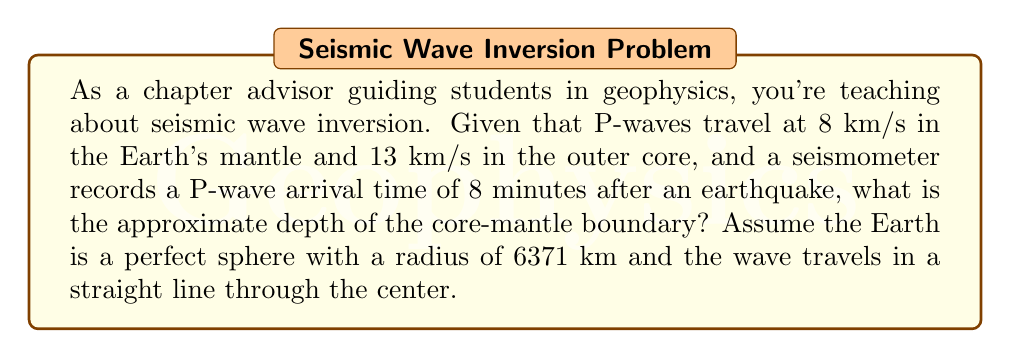Solve this math problem. Let's approach this step-by-step:

1) First, we need to set up our equation. Let $x$ be the distance the wave travels in the mantle, and $y$ be the distance in the core.

2) We know that the total distance is the diameter of the Earth:
   $$x + y = 2 * 6371 = 12742 \text{ km}$$

3) We can express the total time $t$ as the sum of time in mantle and core:
   $$t = \frac{x}{v_m} + \frac{y}{v_c}$$
   where $v_m = 8 \text{ km/s}$ and $v_c = 13 \text{ km/s}$

4) We know $t = 8 \text{ minutes} = 480 \text{ seconds}$. Substituting all known values:
   $$480 = \frac{x}{8} + \frac{12742-x}{13}$$

5) Multiply both sides by 104 (LCM of 8 and 13):
   $$49920 = 13x + 8(12742-x) = 13x + 101936 - 8x = 5x + 101936$$

6) Subtract 101936 from both sides:
   $$-52016 = 5x$$

7) Divide by 5:
   $$x = -10403.2 \text{ km}$$

8) The negative value indicates the wave travels 10403.2 km in the mantle before reaching the core.

9) The depth of the core-mantle boundary is therefore:
   $$6371 - 10403.2/2 = 2169.4 \text{ km}$$
Answer: Approximately 2170 km 